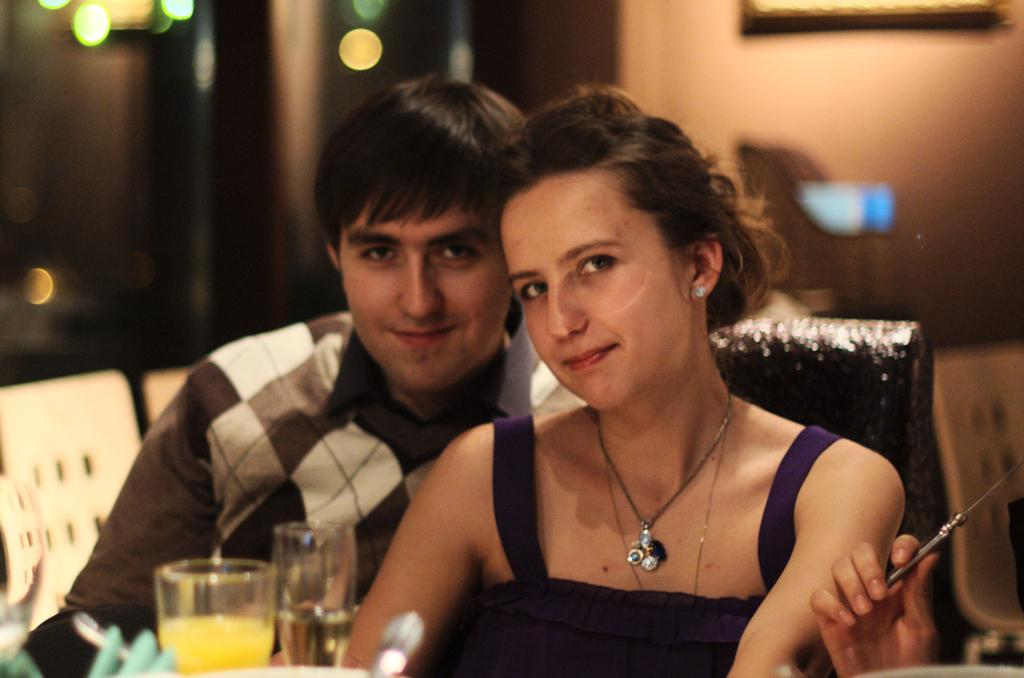How many people are in the image? There is a man and a woman in the image. What is the woman wearing in the image? The woman is wearing a necklace in the image. What objects can be seen in the image besides the people? There are glasses and chairs in the image. What is the quality of the image? The image appears blurred. Whose hand is visible in the image? There is a person's hand holding something in the image. What type of suit is the man wearing in the image? There is no suit visible in the image; the man is not wearing one. Can you see any icicles in the image? There are no icicles present in the image. 